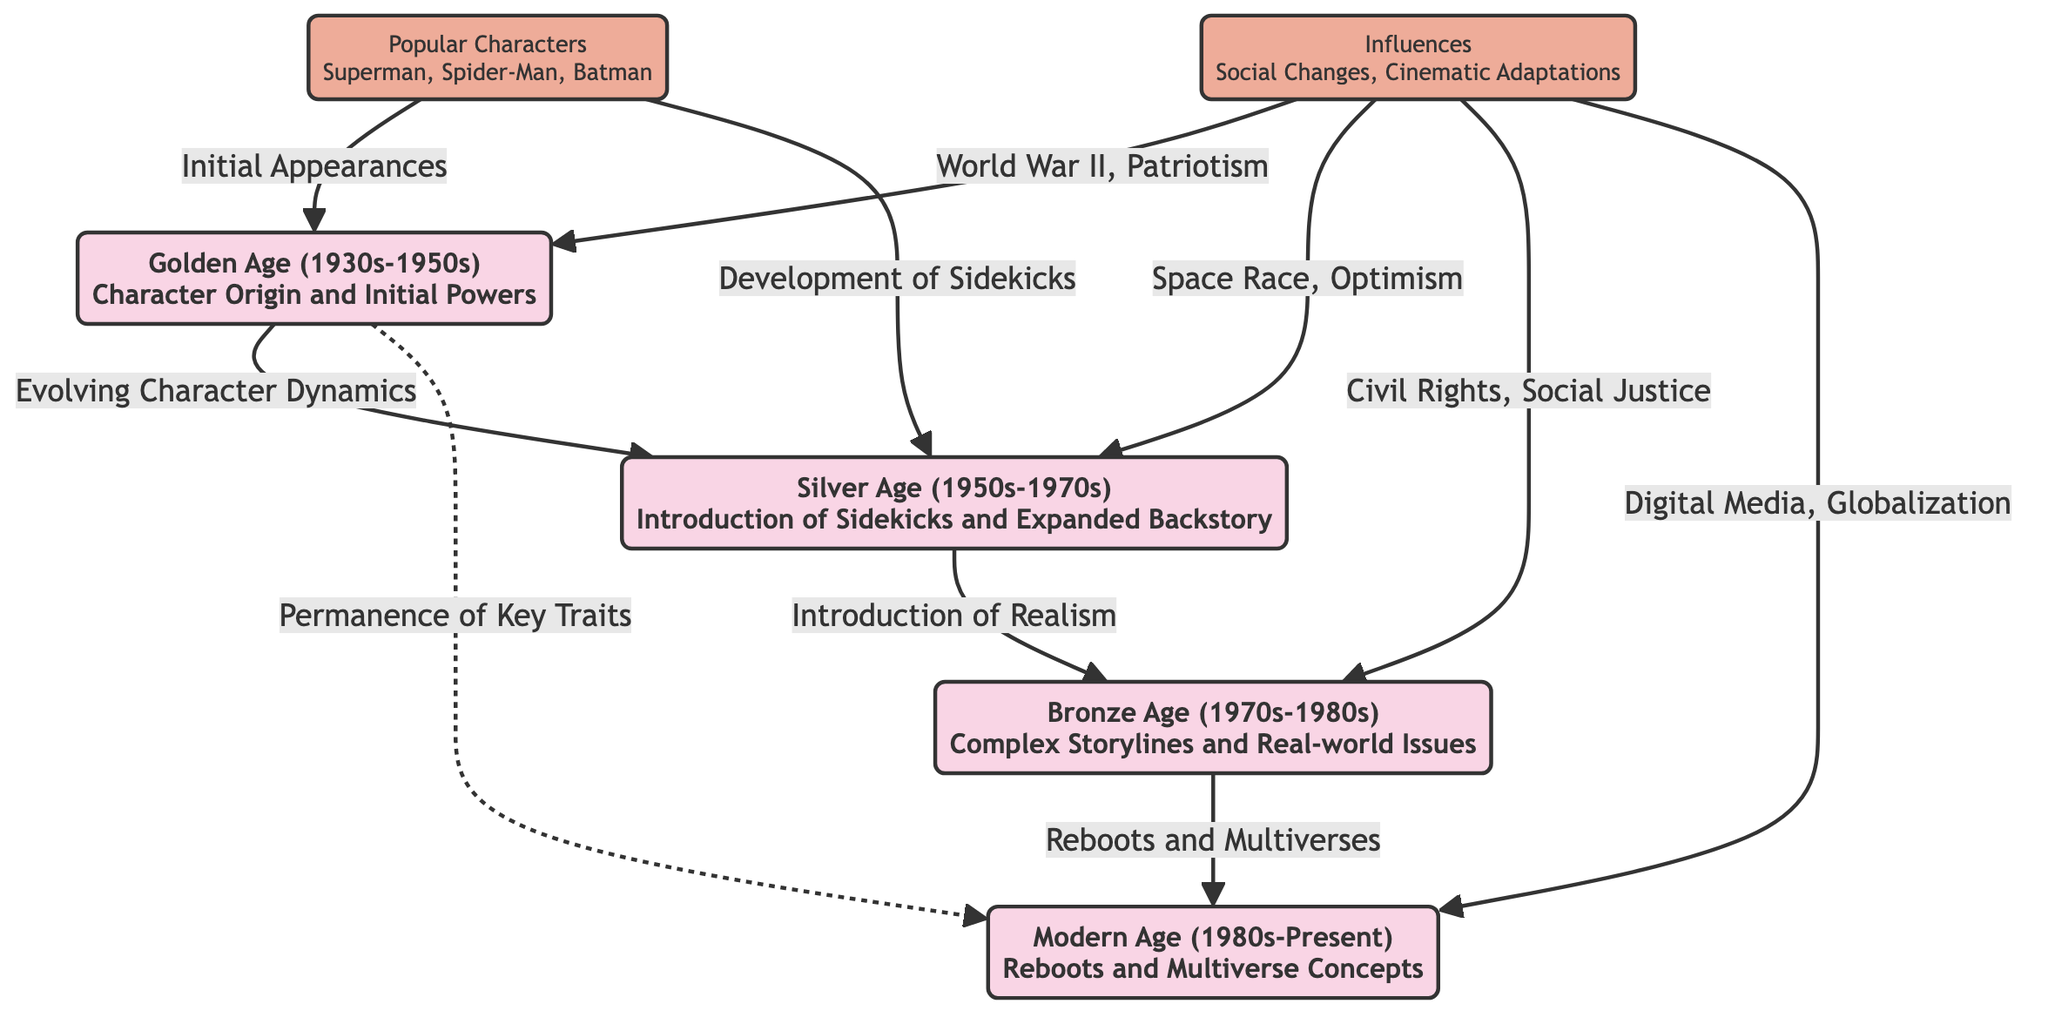What are the four comic eras represented in the diagram? The diagram showcases four comic eras: Golden Age, Silver Age, Bronze Age, and Modern Age. These eras are represented as distinct nodes labeled with their respective timeframes and characteristics.
Answer: Golden Age, Silver Age, Bronze Age, Modern Age What relationship is represented between the Silver Age and the Bronze Age? The diagram indicates a directed relationship from the Silver Age to the Bronze Age, labeled as "Introduction of Realism." This shows the progression in themes from character development to more complex storylines, which is a key aspect of their evolution.
Answer: Introduction of Realism How many popular characters are mentioned in the diagram? The diagram lists popular characters specifically as "Superman, Spider-Man, Batman," which totals three characters depicted in the node. Thus, counting the names provided results in three.
Answer: 3 What influence is associated with the Golden Age? The diagram outlines "World War II, Patriotism" as key influences during the Golden Age. Both elements significantly impacted the themes and character arcs during this period, reflecting societal sentiments.
Answer: World War II, Patriotism In what way does the Golden Age connect to the Modern Age? There is a dotted line connecting the Golden Age to the Modern Age labeled "Permanence of Key Traits." This indicates that while the character's evolution has progressed, some fundamental traits established in the Golden Age continue to influence the Modern Age.
Answer: Permanence of Key Traits What does the Bronze Age reflect in terms of storyline themes? The Bronze Age is described in the diagram with the term "Complex Storylines and Real-world Issues." This highlights the thematic shift towards addressing deeper societal issues and intricate narratives in contrast to earlier eras.
Answer: Complex Storylines and Real-world Issues How do influences transition from the Silver Age to the Bronze Age? The diagram indicates that the theme of the Silver Age revolves around "Space Race, Optimism," which shifts to "Civil Rights, Social Justice" in the Bronze Age. This signifies the evolution of societal influences impacting comic narratives at those times.
Answer: Civil Rights, Social Justice What does the edge connecting the Bronze Age to the Modern Age signify? The edge between the Bronze Age and the Modern Age is labeled "Reboots and Multiverses," demonstrating how storytelling has evolved to include revisiting origins and expansive thematic universes in contemporary comics.
Answer: Reboots and Multiverses 